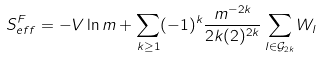<formula> <loc_0><loc_0><loc_500><loc_500>S ^ { F } _ { e f f } = - V \ln m + \sum _ { k \geq 1 } ( - 1 ) ^ { k } \frac { m ^ { - 2 k } } { 2 k ( 2 ) ^ { 2 k } } \sum _ { l \in { \mathcal { G } } _ { 2 k } } W _ { l }</formula> 